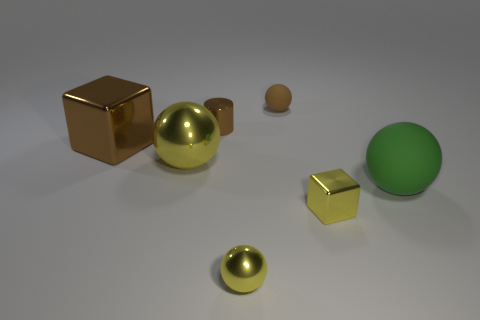Are there any big shiny blocks that have the same color as the tiny shiny cylinder?
Offer a terse response. Yes. There is a small sphere behind the small yellow metal block; is its color the same as the large shiny block?
Give a very brief answer. Yes. There is a yellow sphere in front of the object that is to the right of the small block; how many spheres are right of it?
Offer a terse response. 2. What number of small brown balls are in front of the yellow metallic block?
Offer a terse response. 0. The other small thing that is the same shape as the small matte thing is what color?
Your answer should be compact. Yellow. What is the material of the yellow thing that is left of the brown ball and right of the large yellow metallic thing?
Ensure brevity in your answer.  Metal. There is a yellow sphere that is in front of the green rubber ball; is its size the same as the large rubber ball?
Give a very brief answer. No. What is the brown ball made of?
Offer a terse response. Rubber. There is a small ball in front of the big metallic cube; what color is it?
Offer a very short reply. Yellow. How many large objects are either purple spheres or brown rubber balls?
Give a very brief answer. 0. 